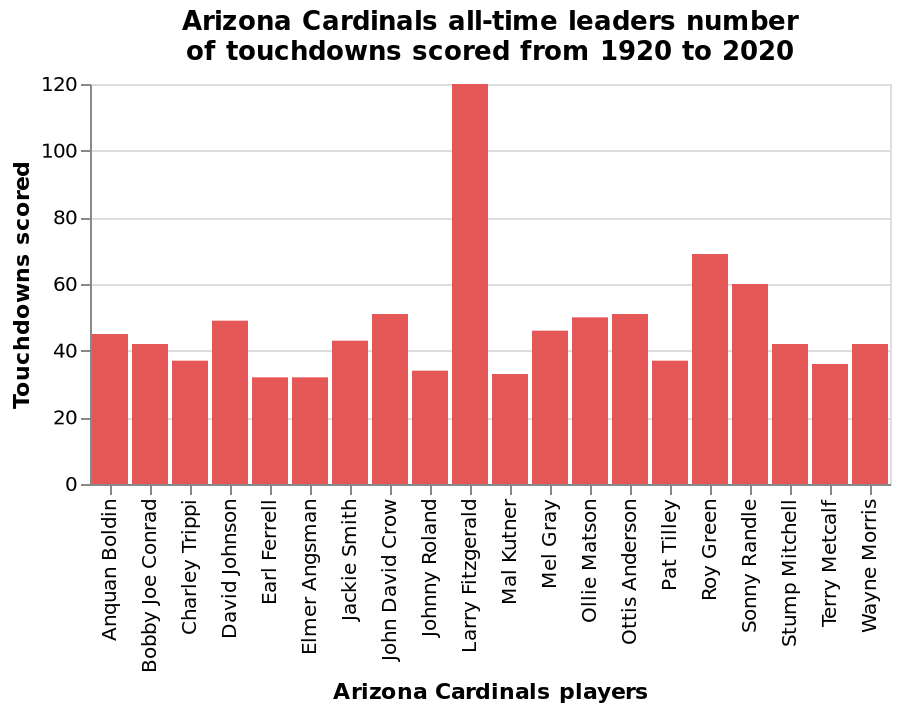<image>
What is the time range covered by the bar graph showing the Arizona Cardinals all-time leaders in touchdowns scored?  The bar graph covers the time period from 1920 to 2020. Which player's name is at the other end of the categorical scale on the x-axis? The player named Wayne Morris is at the other end of the categorical scale on the x-axis. please summary the statistics and relations of the chart Larry Fitzgerald by far has scored the most touchdowns, over 50 more than anyone else.  Only 2 other people have 60 or more out of the 20 people.  More than half have scored over 40. How many touchdowns has Larry Fitzgerald scored? The exact number of touchdowns scored by Larry Fitzgerald is not given in the information provided. 